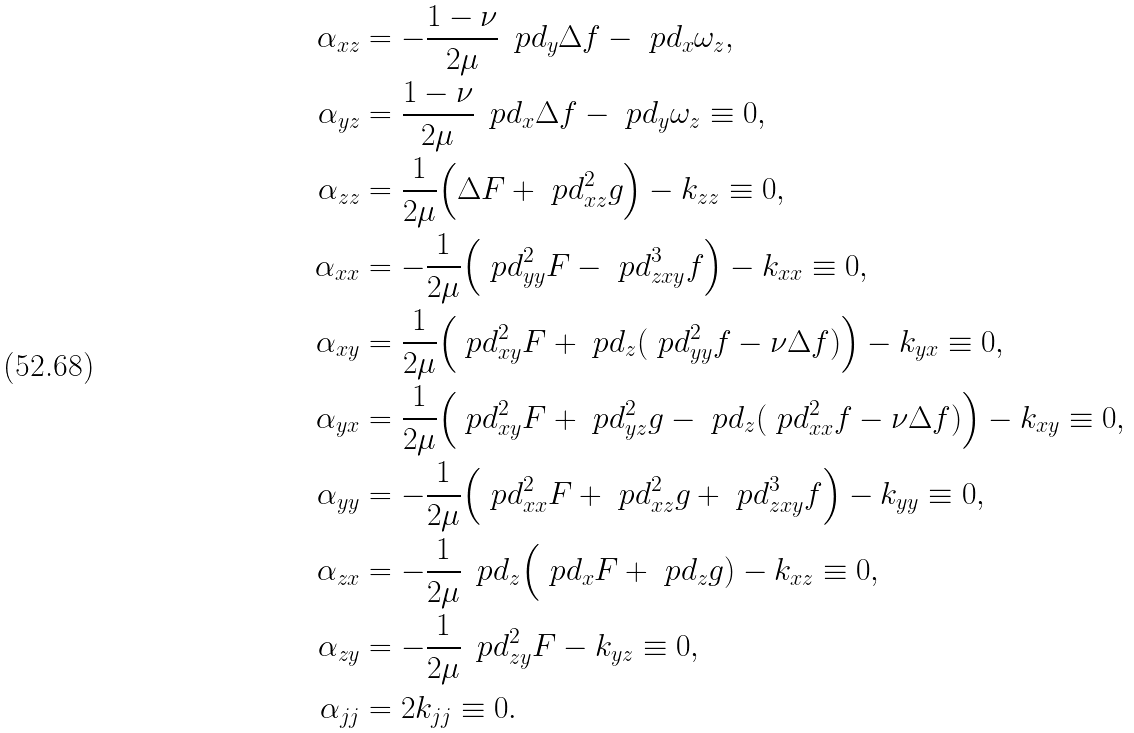<formula> <loc_0><loc_0><loc_500><loc_500>\alpha _ { x z } & = - \frac { 1 - \nu } { 2 \mu } \, \ p d _ { y } \Delta f - \ p d _ { x } \omega _ { z } , \\ \alpha _ { y z } & = \frac { 1 - \nu } { 2 \mu } \, \ p d _ { x } \Delta f - \ p d _ { y } \omega _ { z } \equiv 0 , \\ \alpha _ { z z } & = \frac { 1 } { 2 \mu } \Big ( \Delta F + \ p d ^ { 2 } _ { x z } g \Big ) - k _ { z z } \equiv 0 , \\ \alpha _ { x x } & = - \frac { 1 } { 2 \mu } \Big ( \ p d ^ { 2 } _ { y y } F - \ p d ^ { 3 } _ { z x y } f \Big ) - k _ { x x } \equiv 0 , \\ \alpha _ { x y } & = \frac { 1 } { 2 \mu } \Big ( \ p d ^ { 2 } _ { x y } F + \ p d _ { z } ( \ p d ^ { 2 } _ { y y } f - \nu \Delta f ) \Big ) - k _ { y x } \equiv 0 , \\ \alpha _ { y x } & = \frac { 1 } { 2 \mu } \Big ( \ p d ^ { 2 } _ { x y } F + \ p d ^ { 2 } _ { y z } g - \ p d _ { z } ( \ p d ^ { 2 } _ { x x } f - \nu \Delta f ) \Big ) - k _ { x y } \equiv 0 , \\ \alpha _ { y y } & = - \frac { 1 } { 2 \mu } \Big ( \ p d ^ { 2 } _ { x x } F + \ p d ^ { 2 } _ { x z } g + \ p d ^ { 3 } _ { z x y } f \Big ) - k _ { y y } \equiv 0 , \\ \alpha _ { z x } & = - \frac { 1 } { 2 \mu } \, \ p d _ { z } \Big ( \ p d _ { x } F + \ p d _ { z } g ) - k _ { x z } \equiv 0 , \\ \alpha _ { z y } & = - \frac { 1 } { 2 \mu } \, \ p d ^ { 2 } _ { z y } F - k _ { y z } \equiv 0 , \\ \alpha _ { j j } & = 2 k _ { j j } \equiv 0 .</formula> 